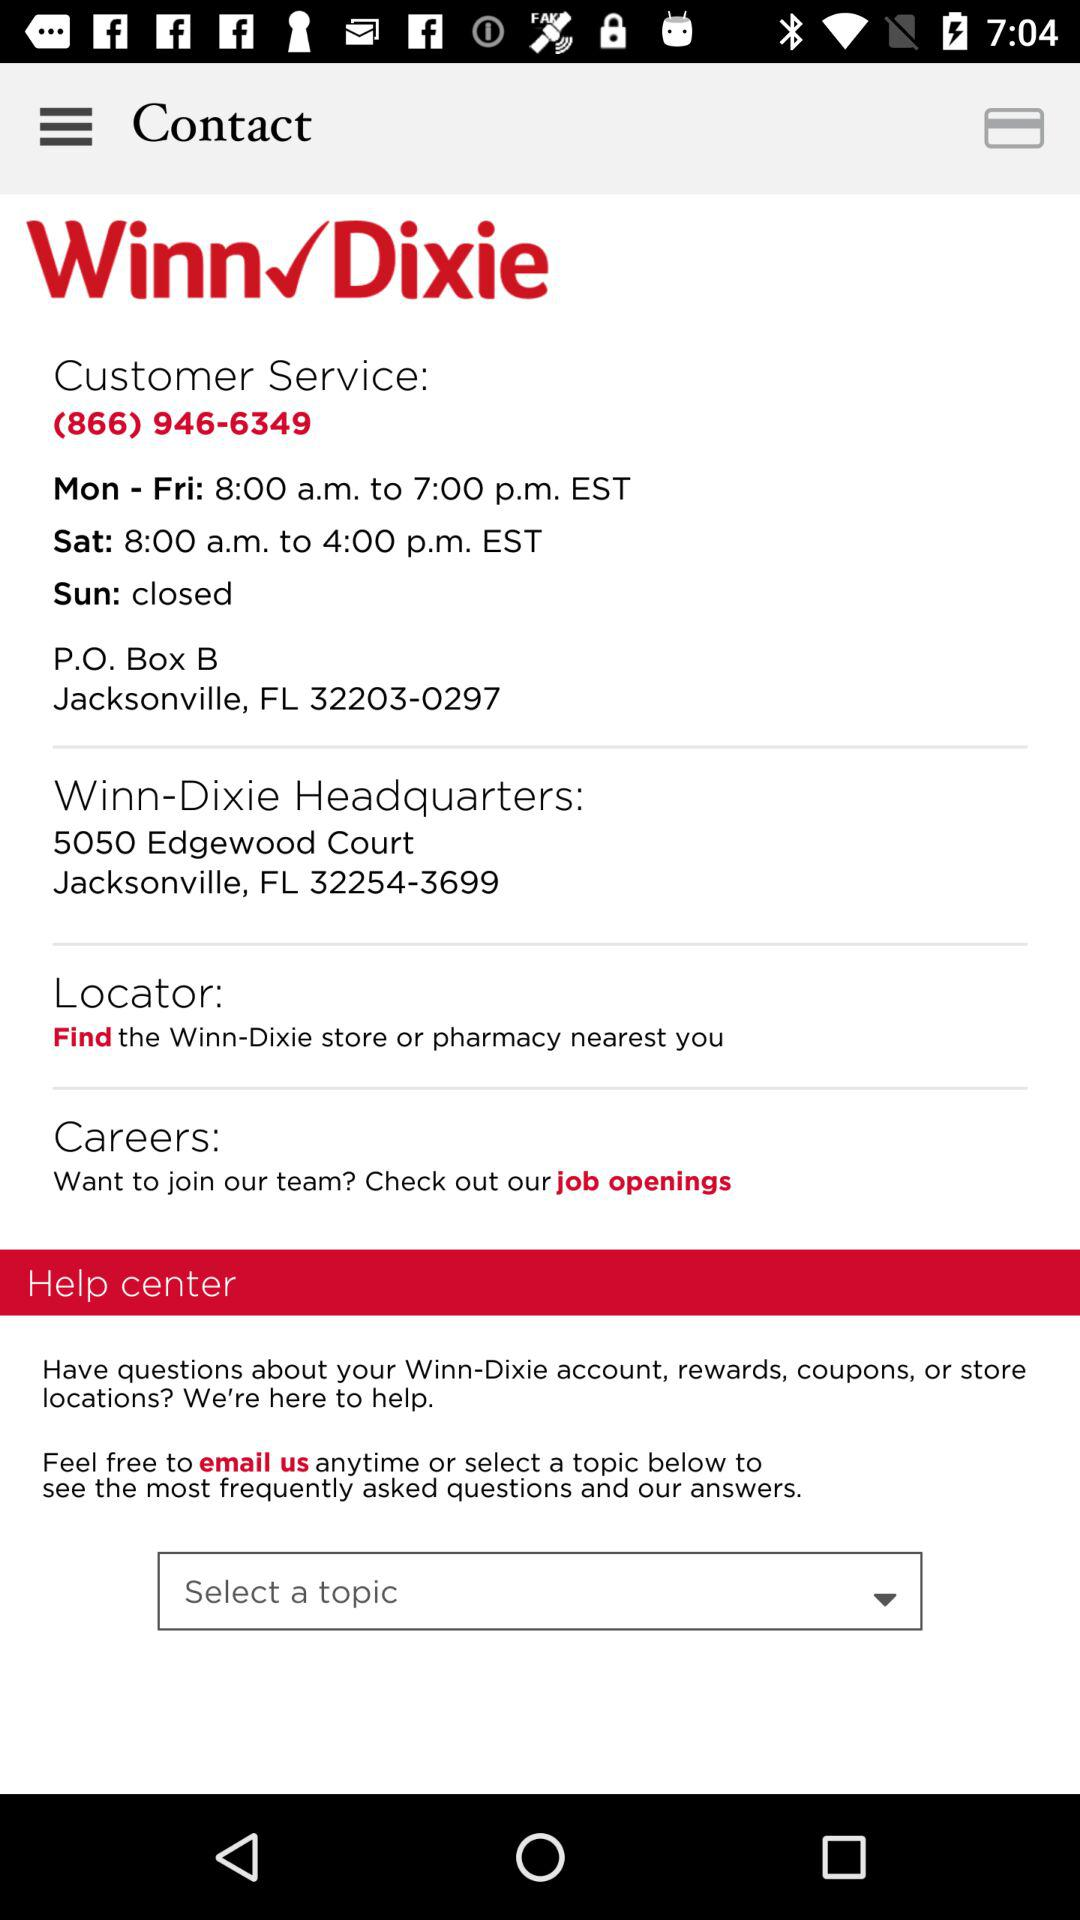What is the customer service number? The customer service number is (866) 946-6349. 